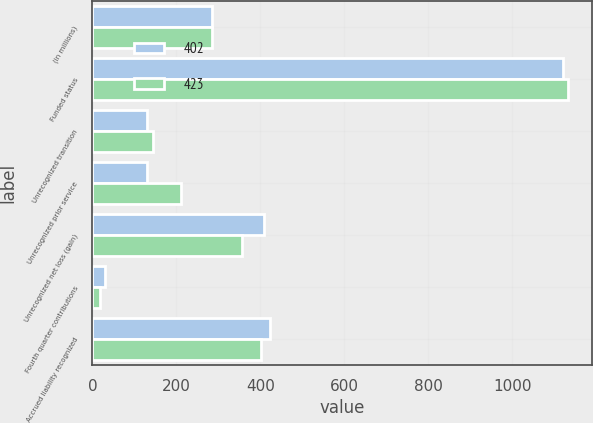<chart> <loc_0><loc_0><loc_500><loc_500><stacked_bar_chart><ecel><fcel>(in millions)<fcel>Funded status<fcel>Unrecognized transition<fcel>Unrecognized prior service<fcel>Unrecognized net loss (gain)<fcel>Fourth quarter contributions<fcel>Accrued liability recognized<nl><fcel>402<fcel>284<fcel>1120<fcel>129<fcel>130<fcel>408<fcel>30<fcel>423<nl><fcel>423<fcel>284<fcel>1133<fcel>144<fcel>211<fcel>357<fcel>19<fcel>402<nl></chart> 